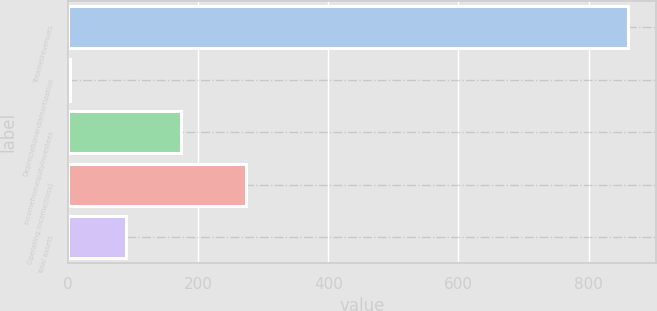Convert chart. <chart><loc_0><loc_0><loc_500><loc_500><bar_chart><fcel>Totalnetrevenues<fcel>Depreciationandamortization<fcel>Incomefromequityinvestees<fcel>Operating income/(loss)<fcel>Total assets<nl><fcel>860.5<fcel>2.4<fcel>174.02<fcel>273<fcel>88.21<nl></chart> 